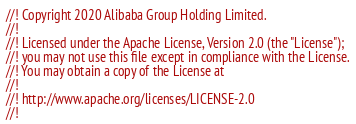<code> <loc_0><loc_0><loc_500><loc_500><_Rust_>//! Copyright 2020 Alibaba Group Holding Limited.
//!
//! Licensed under the Apache License, Version 2.0 (the "License");
//! you may not use this file except in compliance with the License.
//! You may obtain a copy of the License at
//!
//! http://www.apache.org/licenses/LICENSE-2.0
//!</code> 